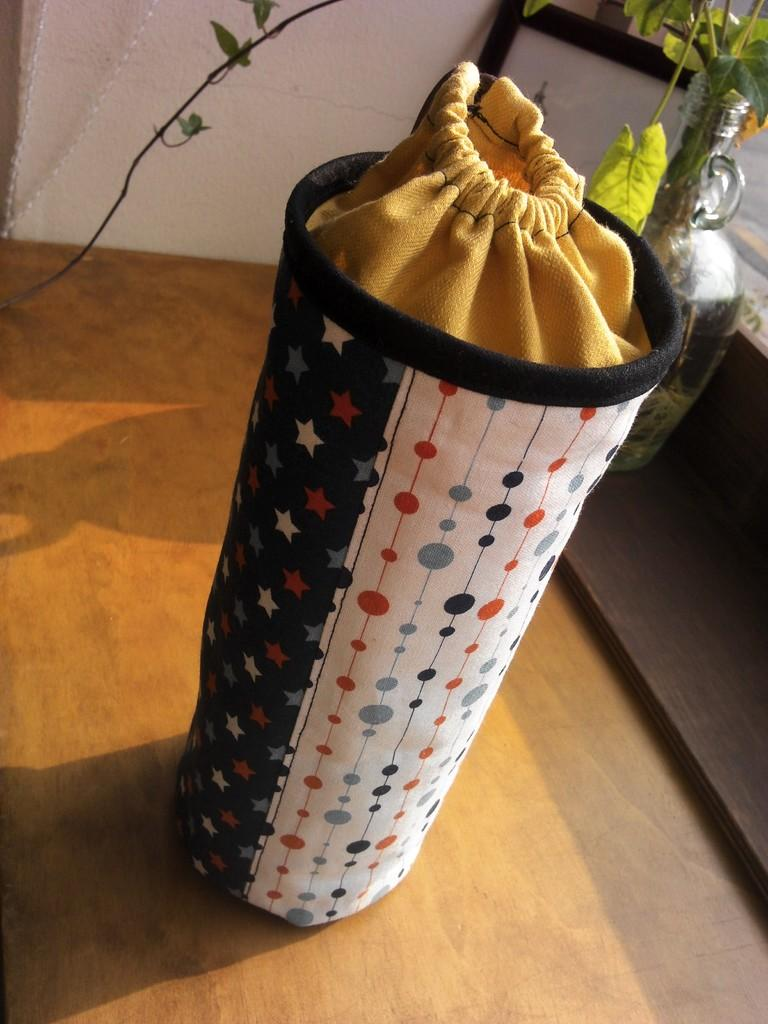What is inside the pouch in the image? There is a sack in the pouch. What type of plants are in the glass pot? There are creepers in a glass pot. What type of structures are visible in the image? There are walls visible in the image. How many rabbits can be seen in the image? There are no rabbits present in the image. What type of pain is being experienced by the creepers in the glass pot? The creepers in the glass pot are plants and do not experience pain. What material is the sack made of, and how does it affect the cork? There is no cork present in the image, and the material of the sack is not mentioned in the provided facts. 